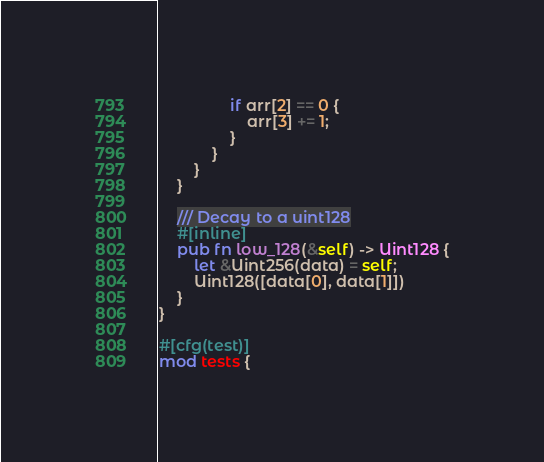<code> <loc_0><loc_0><loc_500><loc_500><_Rust_>                if arr[2] == 0 {
                    arr[3] += 1;
                }
            }
        }
    }

    /// Decay to a uint128
    #[inline]
    pub fn low_128(&self) -> Uint128 {
        let &Uint256(data) = self;
        Uint128([data[0], data[1]])
    }
}

#[cfg(test)]
mod tests {</code> 